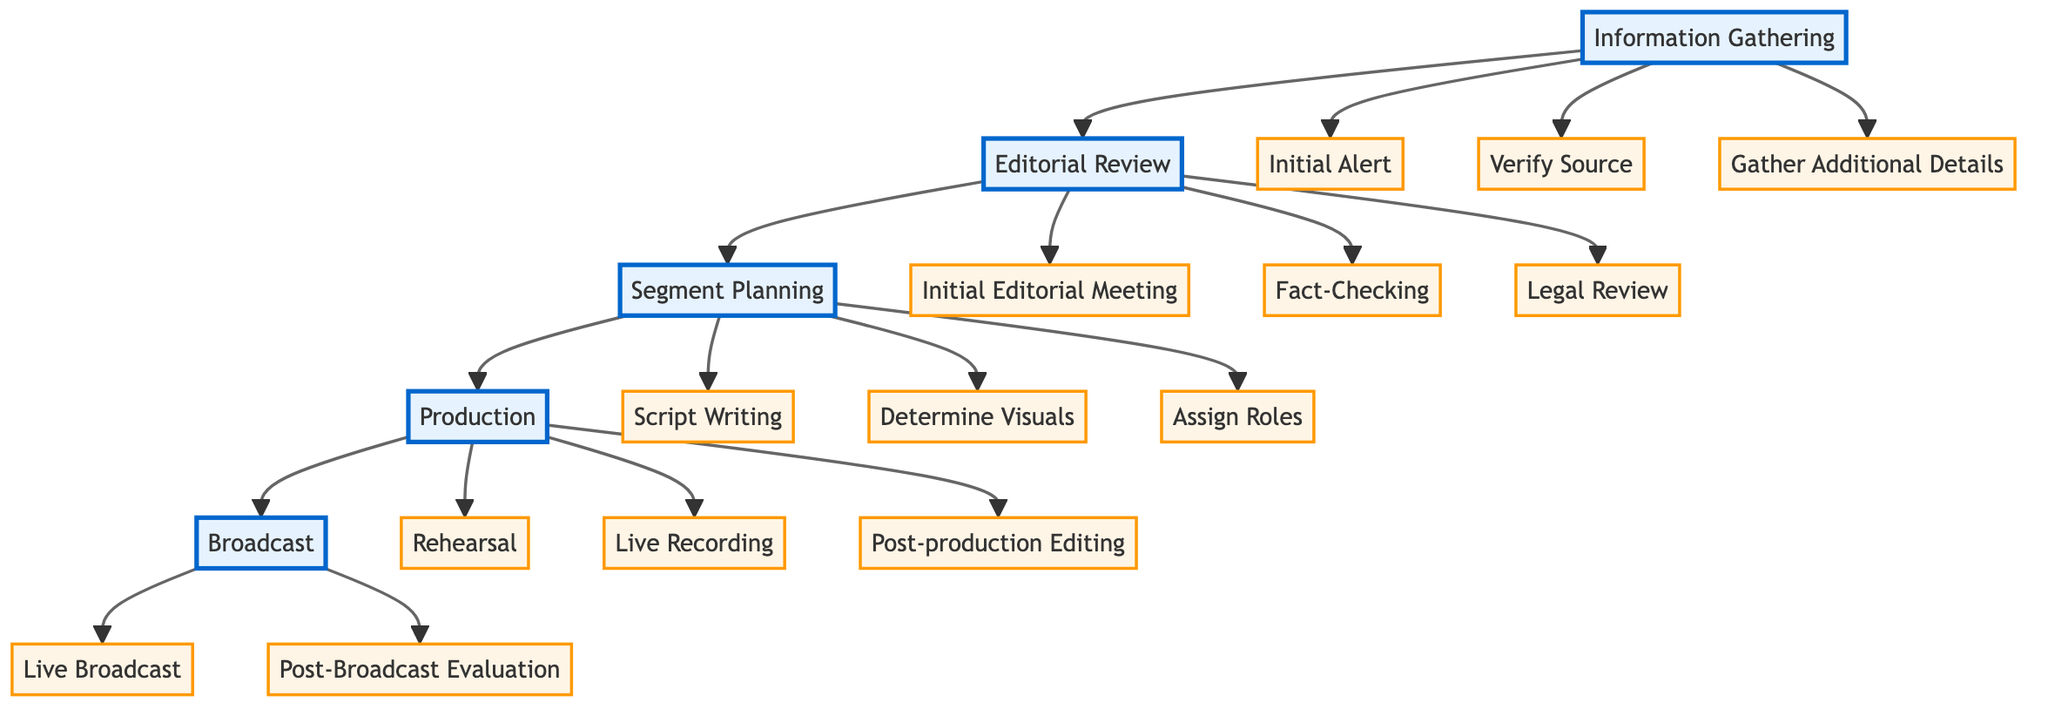What are the first three steps in the Information Gathering phase? The steps are listed under the "Information Gathering" node, which includes "Initial Alert", "Verify Source", and "Gather Additional Details".
Answer: Initial Alert, Verify Source, Gather Additional Details How many steps are in the Editorial Review section? In the "Editorial Review" section, there are three distinct steps: "Initial Editorial Meeting", "Fact-Checking", and "Legal Review". Thus, the total is three.
Answer: 3 What entities are involved in the Fact-Checking step? The "Fact-Checking" step in the "Editorial Review" section lists three entities: "Snopes", "FactCheck.org", and "PolitiFact".
Answer: Snopes, FactCheck.org, PolitiFact Which step follows Segment Planning in the diagram? The flow of the diagram shows that after "Segment Planning", the next step is "Production". This can be determined by looking at the arrows connecting the nodes.
Answer: Production What tools are used for Post-production Editing? The "Post-production Editing" step in the "Production" section indicates the use of specific tools: "Adobe Premiere Pro" and "Final Cut Pro".
Answer: Adobe Premiere Pro, Final Cut Pro What department handles the Post-Broadcast Evaluation? According to the "Broadcast" section, the department responsible for "Post-Broadcast Evaluation" is the "Editorial Team" and the "Production Crew".
Answer: Editorial Team, Production Crew How many main sections are there in the entire procedure? The diagram contains five main sections: "Information Gathering", "Editorial Review", "Segment Planning", "Production", and "Broadcast", making it a total of five.
Answer: 5 Which step is the last in the entire procedure? The last step in the process, as inferred from the diagram flow, is "Post-Broadcast Evaluation", which falls under the "Broadcast" section.
Answer: Post-Broadcast Evaluation What is the immediate initial step following an Initial Alert? After the "Initial Alert" step in the "Information Gathering" stage, the next immediate step is "Verify Source", as indicated by the flow of the diagram.
Answer: Verify Source 